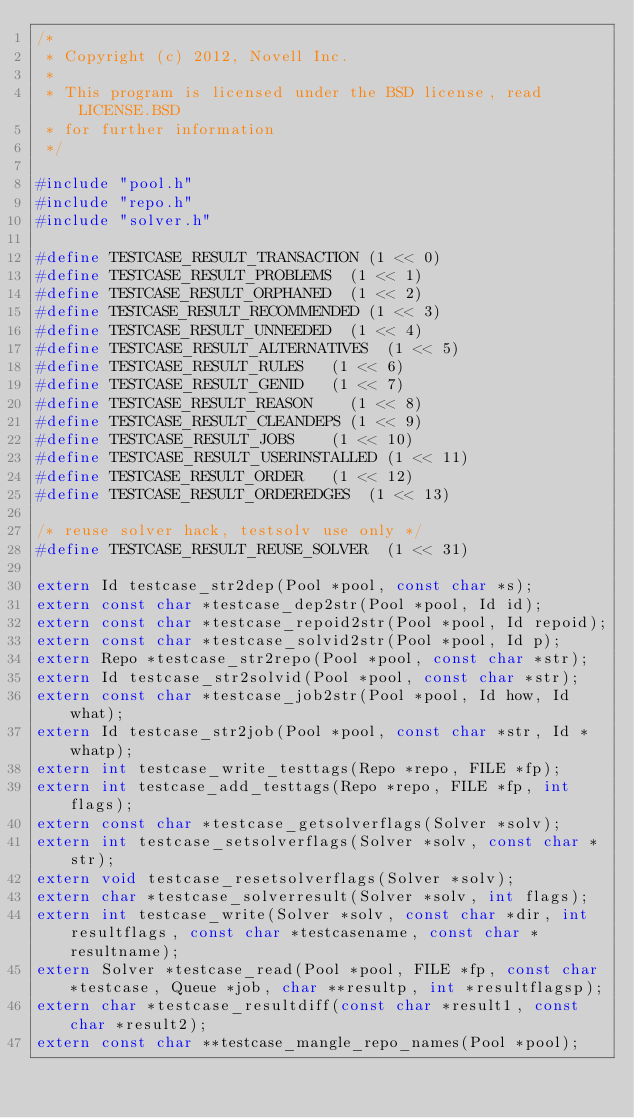Convert code to text. <code><loc_0><loc_0><loc_500><loc_500><_C_>/*
 * Copyright (c) 2012, Novell Inc.
 *
 * This program is licensed under the BSD license, read LICENSE.BSD
 * for further information
 */

#include "pool.h"
#include "repo.h"
#include "solver.h"

#define TESTCASE_RESULT_TRANSACTION	(1 << 0)
#define TESTCASE_RESULT_PROBLEMS	(1 << 1)
#define TESTCASE_RESULT_ORPHANED	(1 << 2)
#define TESTCASE_RESULT_RECOMMENDED	(1 << 3)
#define TESTCASE_RESULT_UNNEEDED	(1 << 4)
#define TESTCASE_RESULT_ALTERNATIVES	(1 << 5)
#define TESTCASE_RESULT_RULES		(1 << 6)
#define TESTCASE_RESULT_GENID		(1 << 7)
#define TESTCASE_RESULT_REASON		(1 << 8)
#define TESTCASE_RESULT_CLEANDEPS	(1 << 9)
#define TESTCASE_RESULT_JOBS		(1 << 10)
#define TESTCASE_RESULT_USERINSTALLED	(1 << 11)
#define TESTCASE_RESULT_ORDER		(1 << 12)
#define TESTCASE_RESULT_ORDEREDGES	(1 << 13)

/* reuse solver hack, testsolv use only */
#define TESTCASE_RESULT_REUSE_SOLVER	(1 << 31)

extern Id testcase_str2dep(Pool *pool, const char *s);
extern const char *testcase_dep2str(Pool *pool, Id id);
extern const char *testcase_repoid2str(Pool *pool, Id repoid);
extern const char *testcase_solvid2str(Pool *pool, Id p);
extern Repo *testcase_str2repo(Pool *pool, const char *str);
extern Id testcase_str2solvid(Pool *pool, const char *str);
extern const char *testcase_job2str(Pool *pool, Id how, Id what);
extern Id testcase_str2job(Pool *pool, const char *str, Id *whatp);
extern int testcase_write_testtags(Repo *repo, FILE *fp);
extern int testcase_add_testtags(Repo *repo, FILE *fp, int flags);
extern const char *testcase_getsolverflags(Solver *solv);
extern int testcase_setsolverflags(Solver *solv, const char *str);
extern void testcase_resetsolverflags(Solver *solv);
extern char *testcase_solverresult(Solver *solv, int flags);
extern int testcase_write(Solver *solv, const char *dir, int resultflags, const char *testcasename, const char *resultname);
extern Solver *testcase_read(Pool *pool, FILE *fp, const char *testcase, Queue *job, char **resultp, int *resultflagsp);
extern char *testcase_resultdiff(const char *result1, const char *result2);
extern const char **testcase_mangle_repo_names(Pool *pool);

</code> 